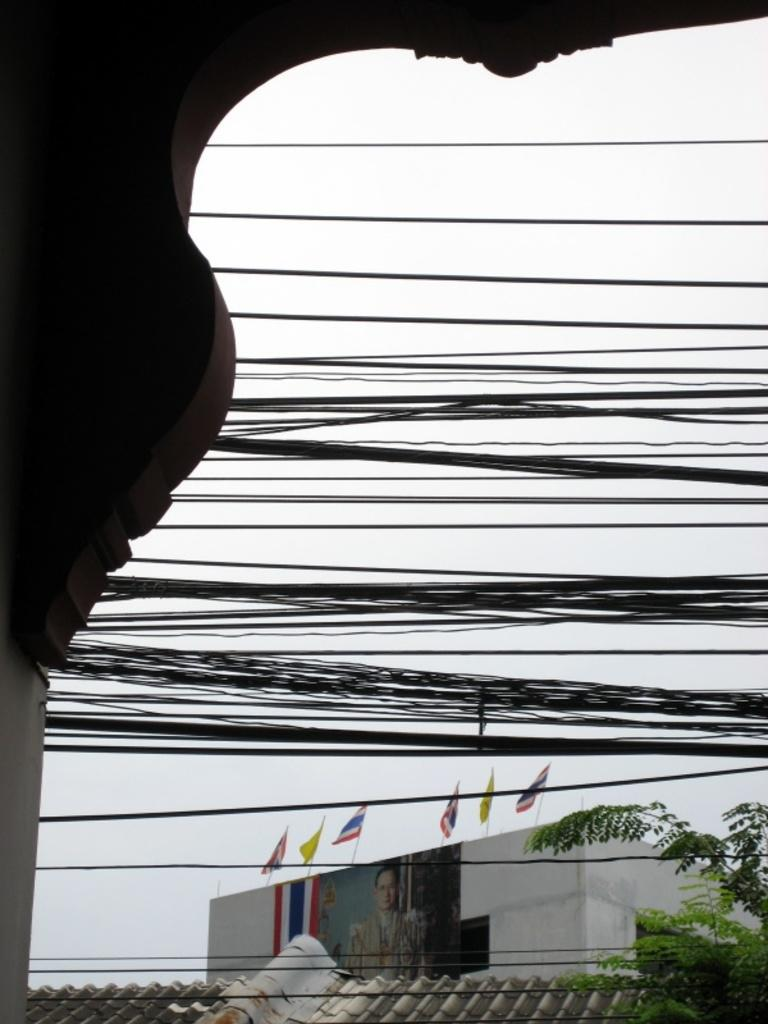What is on the building in the image? There are flags on a building in the image. What type of vegetation can be seen in the image? There is a tree visible in the image. What is above the building in the image? There is a roof in the image. What else can be seen in the image besides the building and tree? There are other objects in the image. What is visible in the background of the image? The sky is visible in the background of the image. How much paste is needed to stick the flags to the building in the image? There is no mention of paste or any adhesive in the image, so it is not possible to determine how much would be needed. 